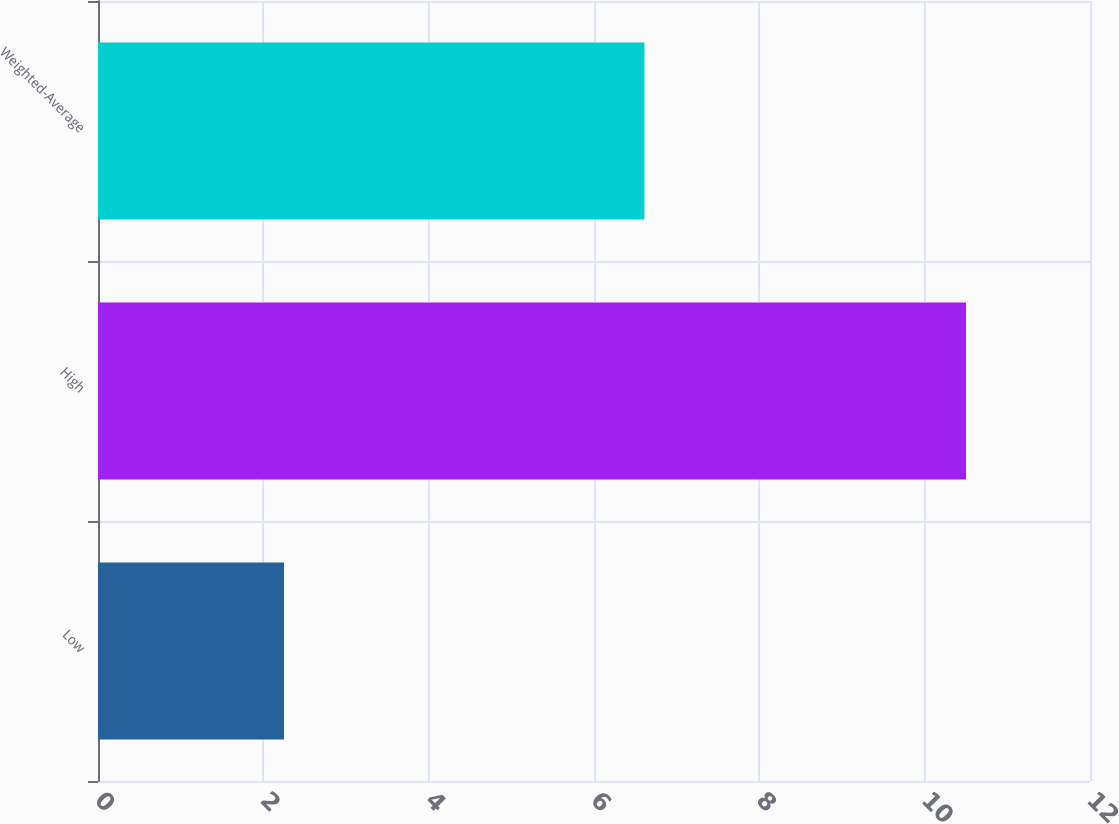<chart> <loc_0><loc_0><loc_500><loc_500><bar_chart><fcel>Low<fcel>High<fcel>Weighted-Average<nl><fcel>2.25<fcel>10.5<fcel>6.61<nl></chart> 